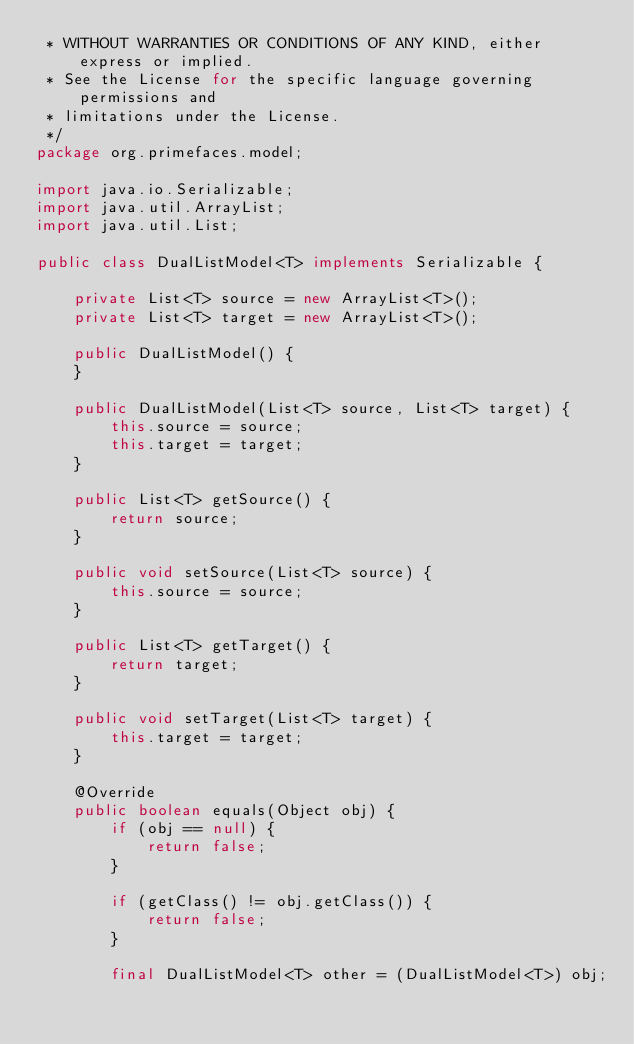<code> <loc_0><loc_0><loc_500><loc_500><_Java_> * WITHOUT WARRANTIES OR CONDITIONS OF ANY KIND, either express or implied.
 * See the License for the specific language governing permissions and
 * limitations under the License.
 */
package org.primefaces.model;

import java.io.Serializable;
import java.util.ArrayList;
import java.util.List;

public class DualListModel<T> implements Serializable {

    private List<T> source = new ArrayList<T>();
    private List<T> target = new ArrayList<T>();

    public DualListModel() {
    }

    public DualListModel(List<T> source, List<T> target) {
        this.source = source;
        this.target = target;
    }

    public List<T> getSource() {
        return source;
    }

    public void setSource(List<T> source) {
        this.source = source;
    }

    public List<T> getTarget() {
        return target;
    }

    public void setTarget(List<T> target) {
        this.target = target;
    }

    @Override
    public boolean equals(Object obj) {
        if (obj == null) {
            return false;
        }

        if (getClass() != obj.getClass()) {
            return false;
        }

        final DualListModel<T> other = (DualListModel<T>) obj;
</code> 